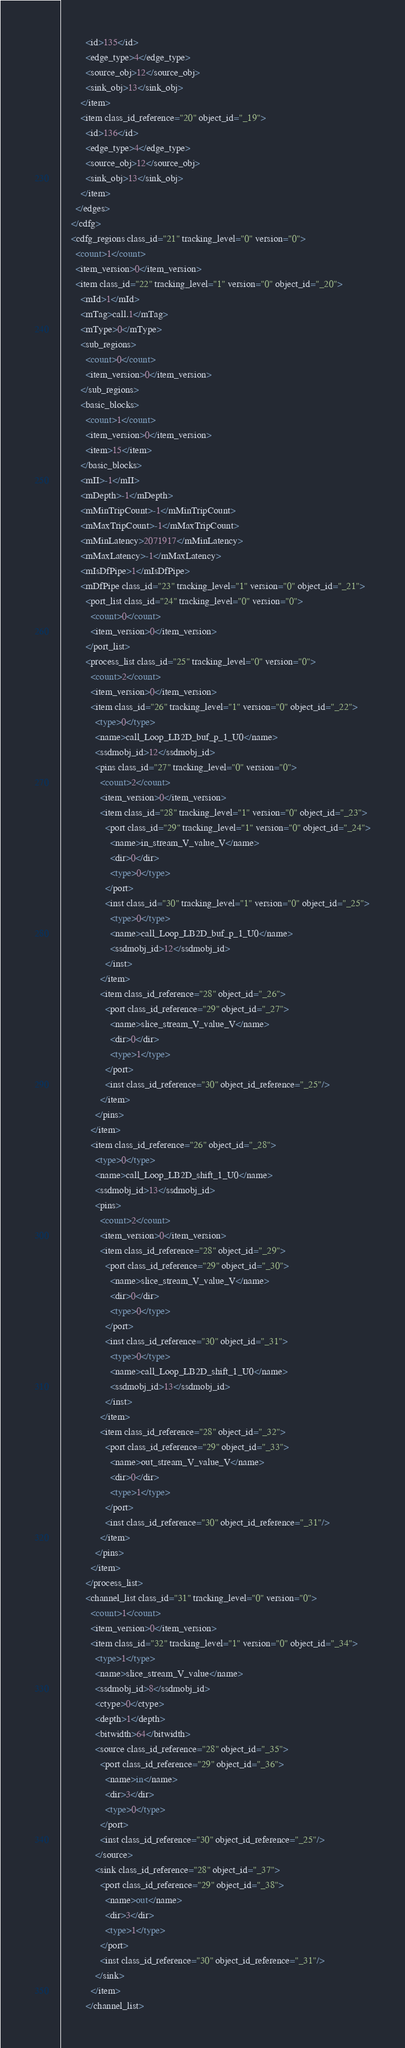Convert code to text. <code><loc_0><loc_0><loc_500><loc_500><_Ada_>          <id>135</id>
          <edge_type>4</edge_type>
          <source_obj>12</source_obj>
          <sink_obj>13</sink_obj>
        </item>
        <item class_id_reference="20" object_id="_19">
          <id>136</id>
          <edge_type>4</edge_type>
          <source_obj>12</source_obj>
          <sink_obj>13</sink_obj>
        </item>
      </edges>
    </cdfg>
    <cdfg_regions class_id="21" tracking_level="0" version="0">
      <count>1</count>
      <item_version>0</item_version>
      <item class_id="22" tracking_level="1" version="0" object_id="_20">
        <mId>1</mId>
        <mTag>call.1</mTag>
        <mType>0</mType>
        <sub_regions>
          <count>0</count>
          <item_version>0</item_version>
        </sub_regions>
        <basic_blocks>
          <count>1</count>
          <item_version>0</item_version>
          <item>15</item>
        </basic_blocks>
        <mII>-1</mII>
        <mDepth>-1</mDepth>
        <mMinTripCount>-1</mMinTripCount>
        <mMaxTripCount>-1</mMaxTripCount>
        <mMinLatency>2071917</mMinLatency>
        <mMaxLatency>-1</mMaxLatency>
        <mIsDfPipe>1</mIsDfPipe>
        <mDfPipe class_id="23" tracking_level="1" version="0" object_id="_21">
          <port_list class_id="24" tracking_level="0" version="0">
            <count>0</count>
            <item_version>0</item_version>
          </port_list>
          <process_list class_id="25" tracking_level="0" version="0">
            <count>2</count>
            <item_version>0</item_version>
            <item class_id="26" tracking_level="1" version="0" object_id="_22">
              <type>0</type>
              <name>call_Loop_LB2D_buf_p_1_U0</name>
              <ssdmobj_id>12</ssdmobj_id>
              <pins class_id="27" tracking_level="0" version="0">
                <count>2</count>
                <item_version>0</item_version>
                <item class_id="28" tracking_level="1" version="0" object_id="_23">
                  <port class_id="29" tracking_level="1" version="0" object_id="_24">
                    <name>in_stream_V_value_V</name>
                    <dir>0</dir>
                    <type>0</type>
                  </port>
                  <inst class_id="30" tracking_level="1" version="0" object_id="_25">
                    <type>0</type>
                    <name>call_Loop_LB2D_buf_p_1_U0</name>
                    <ssdmobj_id>12</ssdmobj_id>
                  </inst>
                </item>
                <item class_id_reference="28" object_id="_26">
                  <port class_id_reference="29" object_id="_27">
                    <name>slice_stream_V_value_V</name>
                    <dir>0</dir>
                    <type>1</type>
                  </port>
                  <inst class_id_reference="30" object_id_reference="_25"/>
                </item>
              </pins>
            </item>
            <item class_id_reference="26" object_id="_28">
              <type>0</type>
              <name>call_Loop_LB2D_shift_1_U0</name>
              <ssdmobj_id>13</ssdmobj_id>
              <pins>
                <count>2</count>
                <item_version>0</item_version>
                <item class_id_reference="28" object_id="_29">
                  <port class_id_reference="29" object_id="_30">
                    <name>slice_stream_V_value_V</name>
                    <dir>0</dir>
                    <type>0</type>
                  </port>
                  <inst class_id_reference="30" object_id="_31">
                    <type>0</type>
                    <name>call_Loop_LB2D_shift_1_U0</name>
                    <ssdmobj_id>13</ssdmobj_id>
                  </inst>
                </item>
                <item class_id_reference="28" object_id="_32">
                  <port class_id_reference="29" object_id="_33">
                    <name>out_stream_V_value_V</name>
                    <dir>0</dir>
                    <type>1</type>
                  </port>
                  <inst class_id_reference="30" object_id_reference="_31"/>
                </item>
              </pins>
            </item>
          </process_list>
          <channel_list class_id="31" tracking_level="0" version="0">
            <count>1</count>
            <item_version>0</item_version>
            <item class_id="32" tracking_level="1" version="0" object_id="_34">
              <type>1</type>
              <name>slice_stream_V_value</name>
              <ssdmobj_id>8</ssdmobj_id>
              <ctype>0</ctype>
              <depth>1</depth>
              <bitwidth>64</bitwidth>
              <source class_id_reference="28" object_id="_35">
                <port class_id_reference="29" object_id="_36">
                  <name>in</name>
                  <dir>3</dir>
                  <type>0</type>
                </port>
                <inst class_id_reference="30" object_id_reference="_25"/>
              </source>
              <sink class_id_reference="28" object_id="_37">
                <port class_id_reference="29" object_id="_38">
                  <name>out</name>
                  <dir>3</dir>
                  <type>1</type>
                </port>
                <inst class_id_reference="30" object_id_reference="_31"/>
              </sink>
            </item>
          </channel_list></code> 